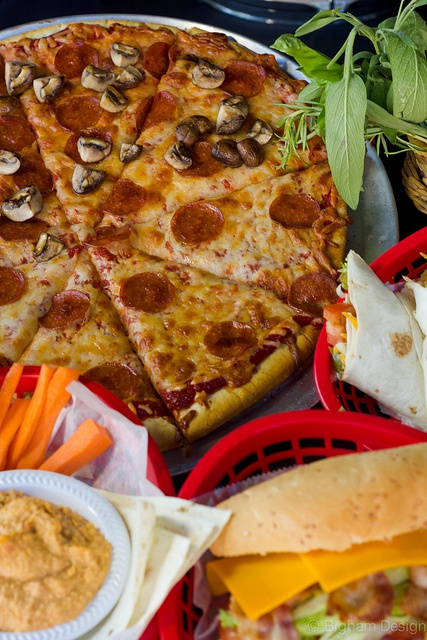Describe the objects in this image and their specific colors. I can see pizza in black, olive, maroon, and tan tones, sandwich in black, tan, orange, and brown tones, potted plant in black, olive, and darkgreen tones, bowl in black, tan, lightgray, orange, and olive tones, and sandwich in black, lightgray, darkgray, and tan tones in this image. 